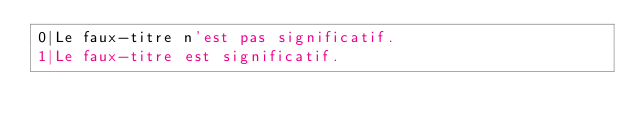Convert code to text. <code><loc_0><loc_0><loc_500><loc_500><_SQL_>0|Le faux-titre n'est pas significatif.
1|Le faux-titre est significatif.
</code> 